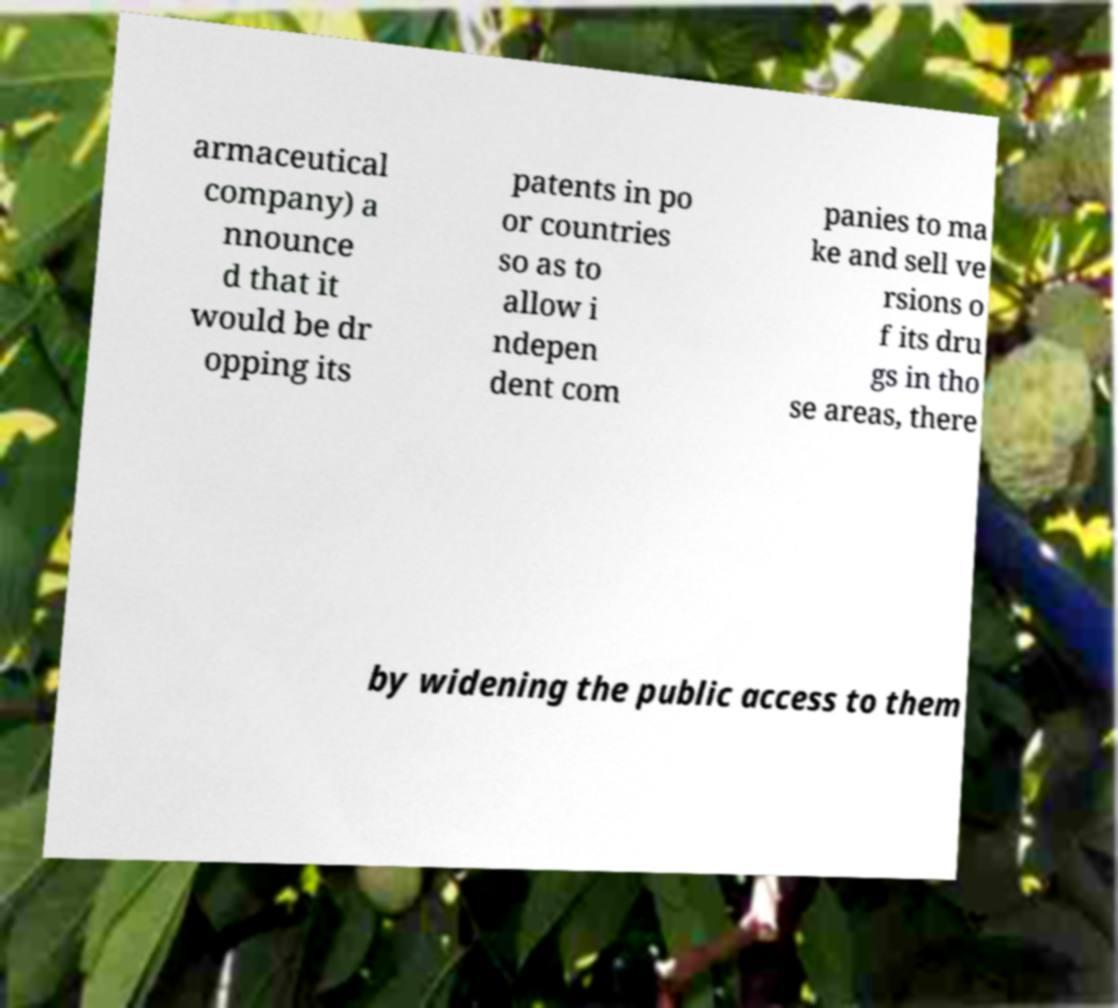Can you accurately transcribe the text from the provided image for me? armaceutical company) a nnounce d that it would be dr opping its patents in po or countries so as to allow i ndepen dent com panies to ma ke and sell ve rsions o f its dru gs in tho se areas, there by widening the public access to them 